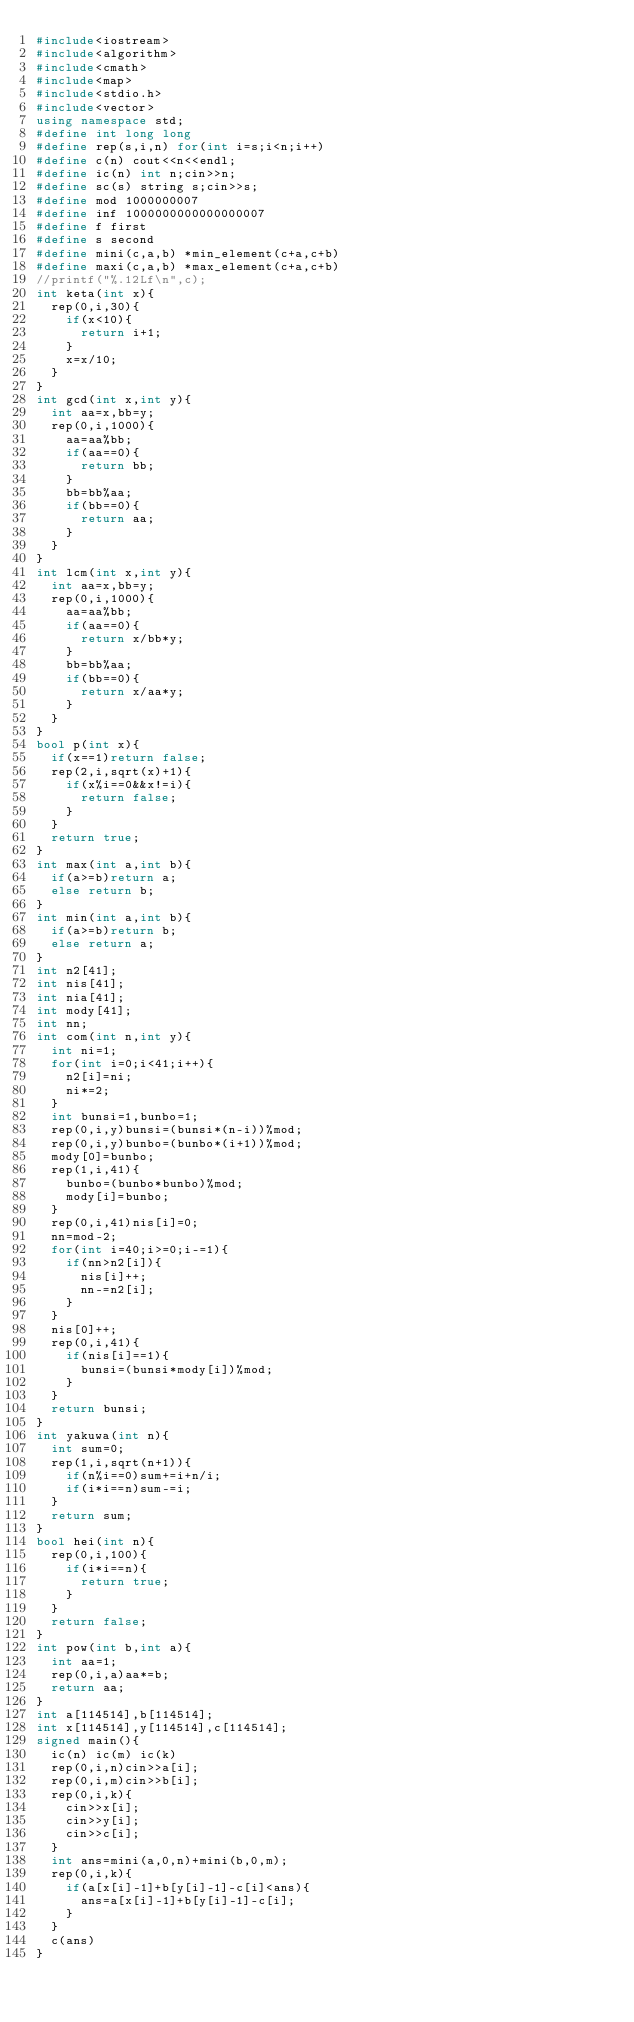<code> <loc_0><loc_0><loc_500><loc_500><_C++_>#include<iostream>
#include<algorithm>
#include<cmath>
#include<map>
#include<stdio.h>
#include<vector>
using namespace std;
#define int long long
#define rep(s,i,n) for(int i=s;i<n;i++)
#define c(n) cout<<n<<endl;
#define ic(n) int n;cin>>n;
#define sc(s) string s;cin>>s;
#define mod 1000000007
#define inf 1000000000000000007
#define f first
#define s second
#define mini(c,a,b) *min_element(c+a,c+b)
#define maxi(c,a,b) *max_element(c+a,c+b)
//printf("%.12Lf\n",c);
int keta(int x){
	rep(0,i,30){
		if(x<10){
			return i+1;
		}
		x=x/10;
	}
}
int gcd(int x,int y){
	int aa=x,bb=y;
	rep(0,i,1000){
		aa=aa%bb;
		if(aa==0){
			return bb;
		}	
		bb=bb%aa;
		if(bb==0){
			return aa;
		}
	}
}	
int lcm(int x,int y){
	int aa=x,bb=y;
	rep(0,i,1000){
		aa=aa%bb;
		if(aa==0){
			return x/bb*y;
		}	
		bb=bb%aa;
		if(bb==0){
			return x/aa*y;
		}
	}
}
bool p(int x){
	if(x==1)return false;
	rep(2,i,sqrt(x)+1){
		if(x%i==0&&x!=i){
			return false;
		}
	}	
	return true;
}
int max(int a,int b){
	if(a>=b)return a;
	else return b;
}
int min(int a,int b){
	if(a>=b)return b;
	else return a;
}	
int n2[41];		
int nis[41]; 
int nia[41];
int mody[41];
int nn;
int com(int n,int y){
	int ni=1;
	for(int i=0;i<41;i++){
		n2[i]=ni;
		ni*=2;
	}
	int bunsi=1,bunbo=1;
	rep(0,i,y)bunsi=(bunsi*(n-i))%mod;
	rep(0,i,y)bunbo=(bunbo*(i+1))%mod;
	mody[0]=bunbo;
	rep(1,i,41){
		bunbo=(bunbo*bunbo)%mod;
		mody[i]=bunbo;
	}
	rep(0,i,41)nis[i]=0;
	nn=mod-2;
	for(int i=40;i>=0;i-=1){
		if(nn>n2[i]){
			nis[i]++;
			nn-=n2[i];
		}
	}
	nis[0]++;
	rep(0,i,41){
		if(nis[i]==1){
			bunsi=(bunsi*mody[i])%mod;
		}
	}
	return bunsi;
}
int yakuwa(int n){
	int sum=0;
	rep(1,i,sqrt(n+1)){
		if(n%i==0)sum+=i+n/i;
		if(i*i==n)sum-=i;
	}
	return sum;
}	
bool hei(int n){
	rep(0,i,100){
		if(i*i==n){
			return true;
		}
	}
	return false;
}
int pow(int b,int a){
	int aa=1;
	rep(0,i,a)aa*=b;	
	return aa;
}		
int a[114514],b[114514];
int x[114514],y[114514],c[114514];
signed main(){
	ic(n) ic(m) ic(k)
	rep(0,i,n)cin>>a[i];
	rep(0,i,m)cin>>b[i];
	rep(0,i,k){
		cin>>x[i];
		cin>>y[i];
		cin>>c[i];
	}
	int ans=mini(a,0,n)+mini(b,0,m);
	rep(0,i,k){
		if(a[x[i]-1]+b[y[i]-1]-c[i]<ans){
			ans=a[x[i]-1]+b[y[i]-1]-c[i];
		}
	}
	c(ans)
}	</code> 